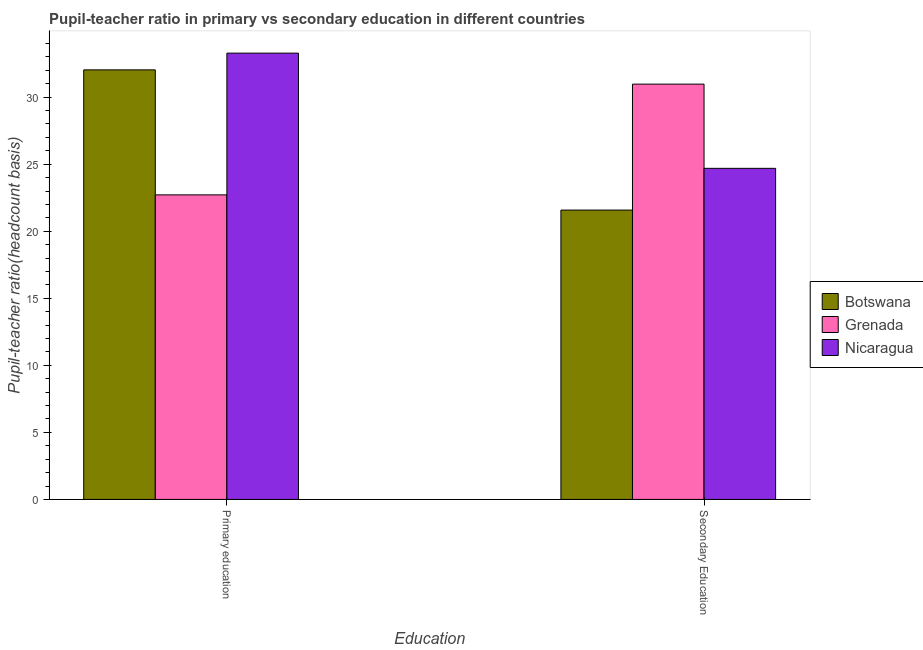How many different coloured bars are there?
Ensure brevity in your answer.  3. Are the number of bars per tick equal to the number of legend labels?
Your response must be concise. Yes. How many bars are there on the 2nd tick from the right?
Ensure brevity in your answer.  3. What is the label of the 1st group of bars from the left?
Provide a succinct answer. Primary education. What is the pupil teacher ratio on secondary education in Botswana?
Your answer should be compact. 21.58. Across all countries, what is the maximum pupil teacher ratio on secondary education?
Your response must be concise. 30.97. Across all countries, what is the minimum pupil-teacher ratio in primary education?
Keep it short and to the point. 22.71. In which country was the pupil teacher ratio on secondary education maximum?
Your answer should be very brief. Grenada. In which country was the pupil teacher ratio on secondary education minimum?
Offer a terse response. Botswana. What is the total pupil teacher ratio on secondary education in the graph?
Keep it short and to the point. 77.24. What is the difference between the pupil-teacher ratio in primary education in Nicaragua and that in Botswana?
Keep it short and to the point. 1.25. What is the difference between the pupil-teacher ratio in primary education in Botswana and the pupil teacher ratio on secondary education in Nicaragua?
Your response must be concise. 7.34. What is the average pupil teacher ratio on secondary education per country?
Offer a very short reply. 25.75. What is the difference between the pupil-teacher ratio in primary education and pupil teacher ratio on secondary education in Nicaragua?
Make the answer very short. 8.59. In how many countries, is the pupil-teacher ratio in primary education greater than 21 ?
Make the answer very short. 3. What is the ratio of the pupil teacher ratio on secondary education in Botswana to that in Grenada?
Give a very brief answer. 0.7. Is the pupil-teacher ratio in primary education in Botswana less than that in Grenada?
Provide a succinct answer. No. In how many countries, is the pupil-teacher ratio in primary education greater than the average pupil-teacher ratio in primary education taken over all countries?
Your answer should be compact. 2. What does the 1st bar from the left in Primary education represents?
Provide a succinct answer. Botswana. What does the 1st bar from the right in Secondary Education represents?
Your response must be concise. Nicaragua. How many bars are there?
Ensure brevity in your answer.  6. What is the difference between two consecutive major ticks on the Y-axis?
Your answer should be very brief. 5. Are the values on the major ticks of Y-axis written in scientific E-notation?
Keep it short and to the point. No. How many legend labels are there?
Provide a succinct answer. 3. What is the title of the graph?
Your answer should be compact. Pupil-teacher ratio in primary vs secondary education in different countries. Does "Paraguay" appear as one of the legend labels in the graph?
Ensure brevity in your answer.  No. What is the label or title of the X-axis?
Ensure brevity in your answer.  Education. What is the label or title of the Y-axis?
Make the answer very short. Pupil-teacher ratio(headcount basis). What is the Pupil-teacher ratio(headcount basis) in Botswana in Primary education?
Offer a terse response. 32.04. What is the Pupil-teacher ratio(headcount basis) of Grenada in Primary education?
Give a very brief answer. 22.71. What is the Pupil-teacher ratio(headcount basis) of Nicaragua in Primary education?
Give a very brief answer. 33.28. What is the Pupil-teacher ratio(headcount basis) of Botswana in Secondary Education?
Offer a terse response. 21.58. What is the Pupil-teacher ratio(headcount basis) of Grenada in Secondary Education?
Your response must be concise. 30.97. What is the Pupil-teacher ratio(headcount basis) of Nicaragua in Secondary Education?
Your answer should be compact. 24.69. Across all Education, what is the maximum Pupil-teacher ratio(headcount basis) in Botswana?
Keep it short and to the point. 32.04. Across all Education, what is the maximum Pupil-teacher ratio(headcount basis) in Grenada?
Your answer should be very brief. 30.97. Across all Education, what is the maximum Pupil-teacher ratio(headcount basis) in Nicaragua?
Your answer should be compact. 33.28. Across all Education, what is the minimum Pupil-teacher ratio(headcount basis) of Botswana?
Make the answer very short. 21.58. Across all Education, what is the minimum Pupil-teacher ratio(headcount basis) of Grenada?
Provide a succinct answer. 22.71. Across all Education, what is the minimum Pupil-teacher ratio(headcount basis) in Nicaragua?
Keep it short and to the point. 24.69. What is the total Pupil-teacher ratio(headcount basis) in Botswana in the graph?
Make the answer very short. 53.61. What is the total Pupil-teacher ratio(headcount basis) of Grenada in the graph?
Provide a short and direct response. 53.68. What is the total Pupil-teacher ratio(headcount basis) in Nicaragua in the graph?
Offer a terse response. 57.98. What is the difference between the Pupil-teacher ratio(headcount basis) in Botswana in Primary education and that in Secondary Education?
Offer a very short reply. 10.46. What is the difference between the Pupil-teacher ratio(headcount basis) in Grenada in Primary education and that in Secondary Education?
Provide a succinct answer. -8.26. What is the difference between the Pupil-teacher ratio(headcount basis) in Nicaragua in Primary education and that in Secondary Education?
Give a very brief answer. 8.59. What is the difference between the Pupil-teacher ratio(headcount basis) in Botswana in Primary education and the Pupil-teacher ratio(headcount basis) in Grenada in Secondary Education?
Keep it short and to the point. 1.06. What is the difference between the Pupil-teacher ratio(headcount basis) of Botswana in Primary education and the Pupil-teacher ratio(headcount basis) of Nicaragua in Secondary Education?
Make the answer very short. 7.34. What is the difference between the Pupil-teacher ratio(headcount basis) of Grenada in Primary education and the Pupil-teacher ratio(headcount basis) of Nicaragua in Secondary Education?
Your answer should be compact. -1.98. What is the average Pupil-teacher ratio(headcount basis) in Botswana per Education?
Your answer should be compact. 26.81. What is the average Pupil-teacher ratio(headcount basis) in Grenada per Education?
Provide a short and direct response. 26.84. What is the average Pupil-teacher ratio(headcount basis) of Nicaragua per Education?
Your answer should be compact. 28.99. What is the difference between the Pupil-teacher ratio(headcount basis) in Botswana and Pupil-teacher ratio(headcount basis) in Grenada in Primary education?
Make the answer very short. 9.32. What is the difference between the Pupil-teacher ratio(headcount basis) in Botswana and Pupil-teacher ratio(headcount basis) in Nicaragua in Primary education?
Provide a short and direct response. -1.25. What is the difference between the Pupil-teacher ratio(headcount basis) of Grenada and Pupil-teacher ratio(headcount basis) of Nicaragua in Primary education?
Your answer should be compact. -10.57. What is the difference between the Pupil-teacher ratio(headcount basis) in Botswana and Pupil-teacher ratio(headcount basis) in Grenada in Secondary Education?
Your response must be concise. -9.39. What is the difference between the Pupil-teacher ratio(headcount basis) of Botswana and Pupil-teacher ratio(headcount basis) of Nicaragua in Secondary Education?
Your answer should be very brief. -3.11. What is the difference between the Pupil-teacher ratio(headcount basis) of Grenada and Pupil-teacher ratio(headcount basis) of Nicaragua in Secondary Education?
Offer a very short reply. 6.28. What is the ratio of the Pupil-teacher ratio(headcount basis) of Botswana in Primary education to that in Secondary Education?
Ensure brevity in your answer.  1.48. What is the ratio of the Pupil-teacher ratio(headcount basis) of Grenada in Primary education to that in Secondary Education?
Provide a succinct answer. 0.73. What is the ratio of the Pupil-teacher ratio(headcount basis) in Nicaragua in Primary education to that in Secondary Education?
Provide a succinct answer. 1.35. What is the difference between the highest and the second highest Pupil-teacher ratio(headcount basis) in Botswana?
Your response must be concise. 10.46. What is the difference between the highest and the second highest Pupil-teacher ratio(headcount basis) in Grenada?
Offer a very short reply. 8.26. What is the difference between the highest and the second highest Pupil-teacher ratio(headcount basis) of Nicaragua?
Your response must be concise. 8.59. What is the difference between the highest and the lowest Pupil-teacher ratio(headcount basis) of Botswana?
Provide a short and direct response. 10.46. What is the difference between the highest and the lowest Pupil-teacher ratio(headcount basis) in Grenada?
Your answer should be very brief. 8.26. What is the difference between the highest and the lowest Pupil-teacher ratio(headcount basis) of Nicaragua?
Offer a terse response. 8.59. 